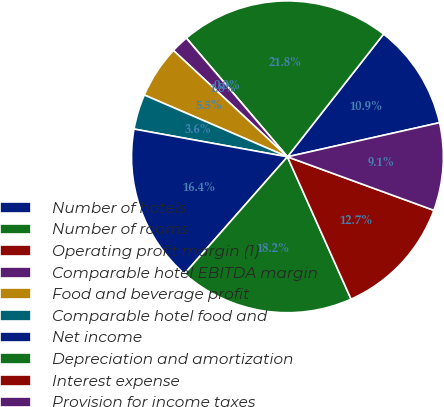<chart> <loc_0><loc_0><loc_500><loc_500><pie_chart><fcel>Number of hotels<fcel>Number of rooms<fcel>Operating profit margin (1)<fcel>Comparable hotel EBITDA margin<fcel>Food and beverage profit<fcel>Comparable hotel food and<fcel>Net income<fcel>Depreciation and amortization<fcel>Interest expense<fcel>Provision for income taxes<nl><fcel>10.91%<fcel>21.81%<fcel>0.0%<fcel>1.82%<fcel>5.46%<fcel>3.64%<fcel>16.36%<fcel>18.18%<fcel>12.73%<fcel>9.09%<nl></chart> 